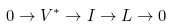<formula> <loc_0><loc_0><loc_500><loc_500>0 \rightarrow V ^ { * } \rightarrow I \rightarrow L \rightarrow 0</formula> 